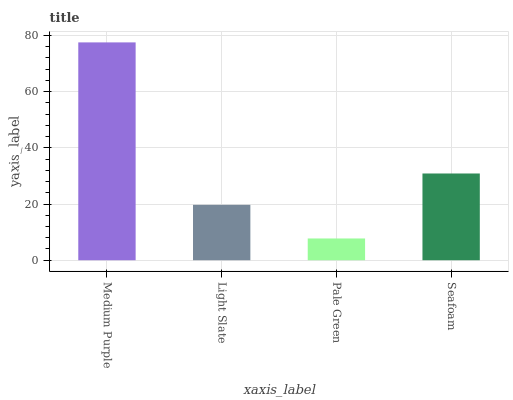Is Light Slate the minimum?
Answer yes or no. No. Is Light Slate the maximum?
Answer yes or no. No. Is Medium Purple greater than Light Slate?
Answer yes or no. Yes. Is Light Slate less than Medium Purple?
Answer yes or no. Yes. Is Light Slate greater than Medium Purple?
Answer yes or no. No. Is Medium Purple less than Light Slate?
Answer yes or no. No. Is Seafoam the high median?
Answer yes or no. Yes. Is Light Slate the low median?
Answer yes or no. Yes. Is Light Slate the high median?
Answer yes or no. No. Is Medium Purple the low median?
Answer yes or no. No. 